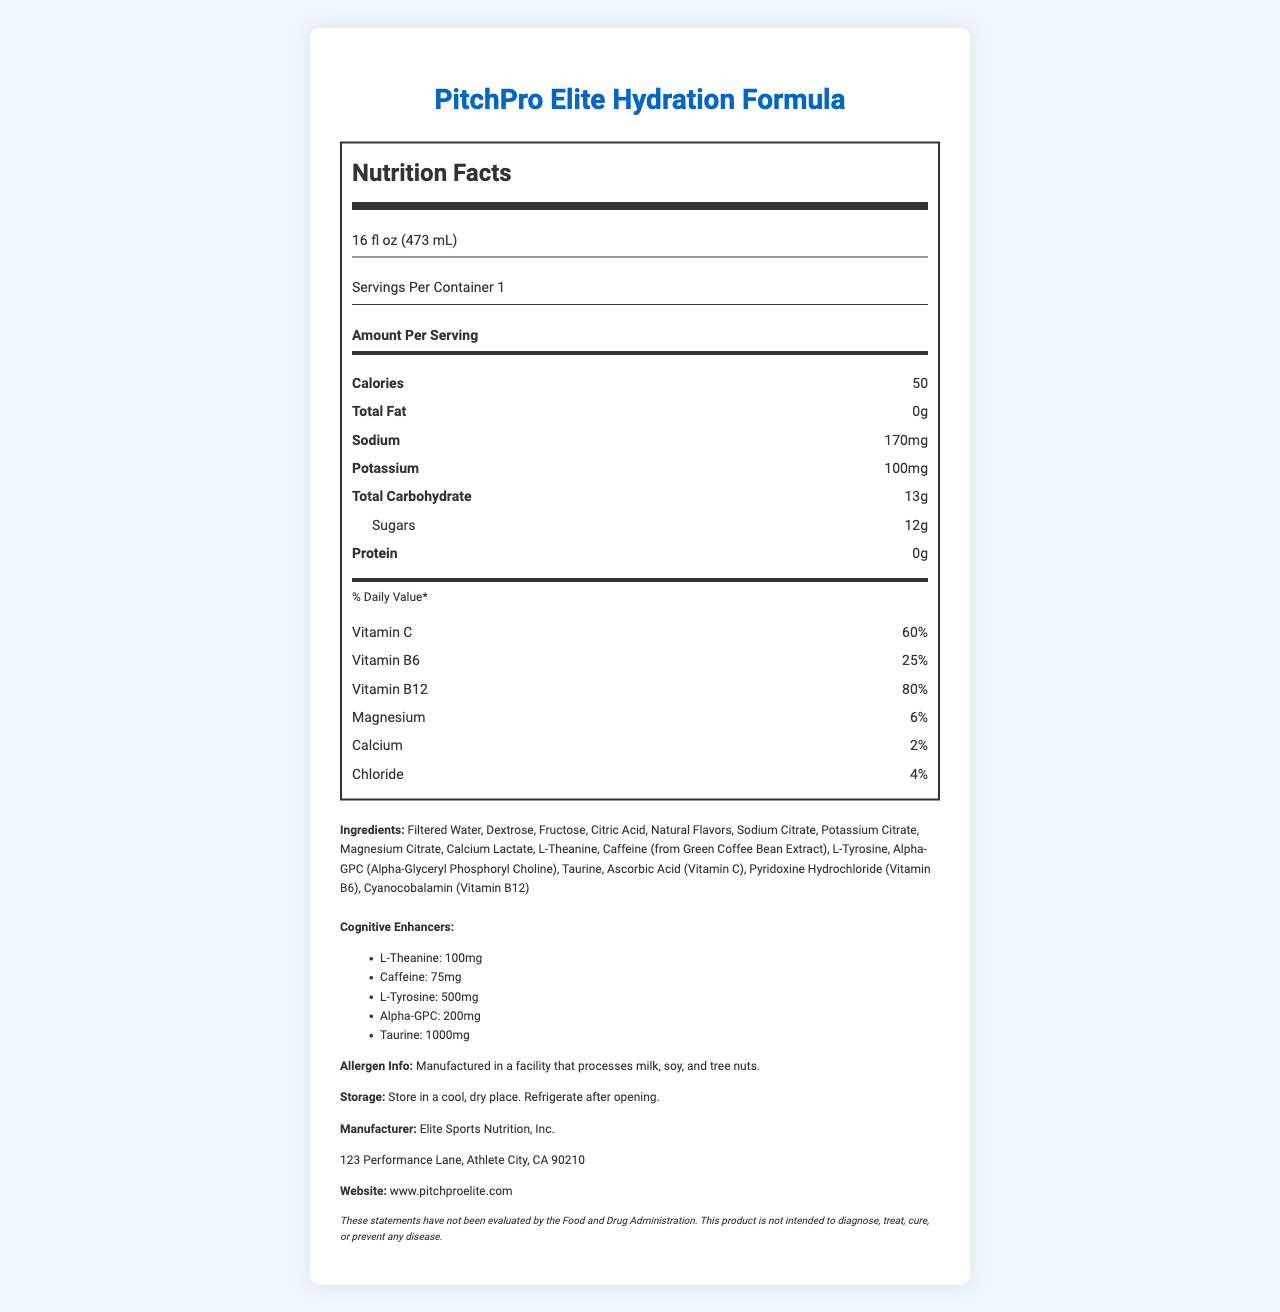What is the serving size of PitchPro Elite Hydration Formula? The serving size is clearly listed as "16 fl oz (473 mL)" in the serving information section of the nutrition label.
Answer: 16 fl oz (473 mL) How many calories are in one serving of PitchPro Elite Hydration Formula? The amount of calories per serving is listed as 50 under the "Amount Per Serving" section.
Answer: 50 What is the total carbohydrate content in one serving? The total carbohydrate content per serving is listed as 13g in the "Amount Per Serving" section.
Answer: 13g Name two cognitive enhancers included in PitchPro Elite Hydration Formula. The cognitive enhancers are listed in the "Cognitive Enhancers" section and include L-Theanine and Caffeine among others.
Answer: L-Theanine, Caffeine What percentage of Vitamin B12 does one serving contain? The percentage of daily value for Vitamin B12 is listed as 80% under the "% Daily Value" section.
Answer: 80% Which ingredient is used as the main source of Vitamin C in PitchPro Elite Hydration Formula? Ascorbic Acid is listed in the ingredients section and is known as the source of Vitamin C.
Answer: Ascorbic Acid Which of the following electrolytes is present in the highest amount per serving? 1. Sodium, 2. Potassium, 3. Magnesium, 4. Calcium Sodium is the highest with 170mg compared to Potassium (100mg), Magnesium (6%), and Calcium (2%).
Answer: 1. Sodium How many grams of sugar does a single serving contain? A. 5g, B. 10g, C. 12g, D. 15g The nutrition label lists the sugars content per serving as 12g which corresponds to option C.
Answer: C. 12g Does PitchPro Elite Hydration Formula contain protein? Yes/No The nutrition label clearly states that the protein content per serving is 0g.
Answer: No Summarize the main features of PitchPro Elite Hydration Formula. This summary captures the key nutritional and functional features of the hydration drink, including its caloric content, key ingredients, and intended benefits.
Answer: PitchPro Elite Hydration Formula is a hydration drink with added electrolytes and cognitive enhancers designed to improve pitching performance. It contains 50 calories per 16 fl oz serving, with key electrolytes like Sodium (170mg) and Potassium (100mg). The formula also includes cognitive enhancers such as L-Theanine, Caffeine, L-Tyrosine, Alpha-GPC, and Taurine. The product provides significant amounts of vitamins B12 and C but contains no fat or protein. The drink is manufactured by Elite Sports Nutrition, Inc., and includes a disclaimer that the statements have not been evaluated by the FDA. What is the source of caffeine in the product? The source of caffeine is indicated as "Caffeine (from Green Coffee Bean Extract)" in the ingredients list.
Answer: Green Coffee Bean Extract Which mineral is present in a lower percentage, Calcium or Magnesium? The nutrition label shows Calcium at 2% compared to Magnesium at 6%, indicating that Calcium is present in a lower percentage.
Answer: Calcium Are there any allergens noted for PitchPro Elite Hydration Formula? The allergen information indicates that the product is manufactured in a facility that processes milk, soy, and tree nuts.
Answer: Yes Can this product diagnose or cure medical conditions? The disclaimer clearly states that this product is not intended to diagnose, treat, cure, or prevent any disease.
Answer: No What is the address of the manufacturing company? The address is listed as "123 Performance Lane, Athlete City, CA 90210" in the additional information section.
Answer: 123 Performance Lane, Athlete City, CA 90210 Who is the target audience for PitchPro Elite Hydration Formula? The document does not provide specific information about the target audience, other than its potential use for improved pitching performance.
Answer: Cannot be determined 